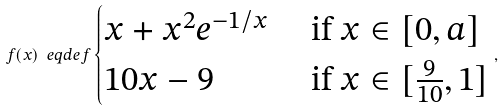Convert formula to latex. <formula><loc_0><loc_0><loc_500><loc_500>f ( x ) \ e q d e f \begin{cases} x + x ^ { 2 } e ^ { - 1 / x } & \text { if } x \in [ 0 , a ] \\ 1 0 x - 9 & \text { if } x \in [ \frac { 9 } { 1 0 } , 1 ] \end{cases} ,</formula> 